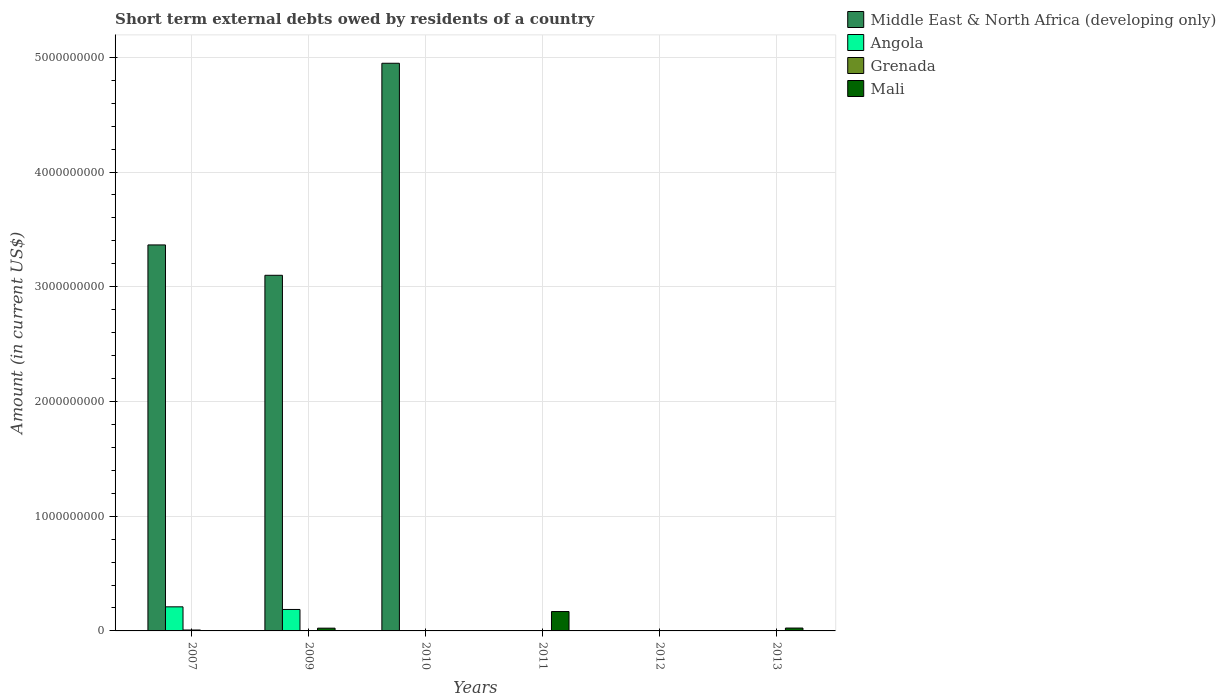How many different coloured bars are there?
Make the answer very short. 4. How many bars are there on the 3rd tick from the left?
Give a very brief answer. 2. How many bars are there on the 5th tick from the right?
Give a very brief answer. 3. What is the label of the 3rd group of bars from the left?
Offer a very short reply. 2010. What is the amount of short-term external debts owed by residents in Mali in 2011?
Provide a short and direct response. 1.69e+08. Across all years, what is the maximum amount of short-term external debts owed by residents in Grenada?
Your answer should be very brief. 8.00e+06. Across all years, what is the minimum amount of short-term external debts owed by residents in Angola?
Make the answer very short. 0. In which year was the amount of short-term external debts owed by residents in Middle East & North Africa (developing only) maximum?
Provide a succinct answer. 2010. What is the total amount of short-term external debts owed by residents in Angola in the graph?
Make the answer very short. 3.97e+08. What is the difference between the amount of short-term external debts owed by residents in Angola in 2007 and that in 2009?
Your response must be concise. 2.30e+07. What is the difference between the amount of short-term external debts owed by residents in Mali in 2011 and the amount of short-term external debts owed by residents in Middle East & North Africa (developing only) in 2010?
Provide a short and direct response. -4.78e+09. What is the average amount of short-term external debts owed by residents in Mali per year?
Ensure brevity in your answer.  3.63e+07. In the year 2013, what is the difference between the amount of short-term external debts owed by residents in Angola and amount of short-term external debts owed by residents in Mali?
Provide a succinct answer. -2.46e+07. What is the ratio of the amount of short-term external debts owed by residents in Angola in 2009 to that in 2013?
Provide a succinct answer. 424.04. Is the amount of short-term external debts owed by residents in Mali in 2009 less than that in 2013?
Your answer should be very brief. Yes. What is the difference between the highest and the second highest amount of short-term external debts owed by residents in Middle East & North Africa (developing only)?
Provide a short and direct response. 1.58e+09. What is the difference between the highest and the lowest amount of short-term external debts owed by residents in Middle East & North Africa (developing only)?
Provide a succinct answer. 4.95e+09. In how many years, is the amount of short-term external debts owed by residents in Mali greater than the average amount of short-term external debts owed by residents in Mali taken over all years?
Offer a terse response. 1. Is the sum of the amount of short-term external debts owed by residents in Mali in 2009 and 2011 greater than the maximum amount of short-term external debts owed by residents in Middle East & North Africa (developing only) across all years?
Ensure brevity in your answer.  No. Is it the case that in every year, the sum of the amount of short-term external debts owed by residents in Grenada and amount of short-term external debts owed by residents in Middle East & North Africa (developing only) is greater than the amount of short-term external debts owed by residents in Angola?
Keep it short and to the point. No. How many bars are there?
Provide a succinct answer. 11. Are all the bars in the graph horizontal?
Offer a very short reply. No. How many years are there in the graph?
Your answer should be compact. 6. Are the values on the major ticks of Y-axis written in scientific E-notation?
Your response must be concise. No. What is the title of the graph?
Give a very brief answer. Short term external debts owed by residents of a country. What is the label or title of the X-axis?
Offer a very short reply. Years. What is the label or title of the Y-axis?
Provide a short and direct response. Amount (in current US$). What is the Amount (in current US$) of Middle East & North Africa (developing only) in 2007?
Provide a short and direct response. 3.36e+09. What is the Amount (in current US$) in Angola in 2007?
Give a very brief answer. 2.10e+08. What is the Amount (in current US$) of Mali in 2007?
Give a very brief answer. 0. What is the Amount (in current US$) in Middle East & North Africa (developing only) in 2009?
Your response must be concise. 3.10e+09. What is the Amount (in current US$) in Angola in 2009?
Offer a terse response. 1.87e+08. What is the Amount (in current US$) of Grenada in 2009?
Your answer should be very brief. 0. What is the Amount (in current US$) of Mali in 2009?
Your response must be concise. 2.40e+07. What is the Amount (in current US$) of Middle East & North Africa (developing only) in 2010?
Offer a terse response. 4.95e+09. What is the Amount (in current US$) in Angola in 2010?
Your answer should be very brief. 0. What is the Amount (in current US$) of Mali in 2010?
Provide a succinct answer. 0. What is the Amount (in current US$) in Angola in 2011?
Provide a short and direct response. 0. What is the Amount (in current US$) in Mali in 2011?
Your answer should be compact. 1.69e+08. What is the Amount (in current US$) of Angola in 2012?
Your answer should be compact. 0. What is the Amount (in current US$) of Mali in 2012?
Keep it short and to the point. 0. What is the Amount (in current US$) of Middle East & North Africa (developing only) in 2013?
Your answer should be compact. 0. What is the Amount (in current US$) of Angola in 2013?
Provide a short and direct response. 4.41e+05. What is the Amount (in current US$) of Mali in 2013?
Offer a terse response. 2.50e+07. Across all years, what is the maximum Amount (in current US$) in Middle East & North Africa (developing only)?
Give a very brief answer. 4.95e+09. Across all years, what is the maximum Amount (in current US$) in Angola?
Make the answer very short. 2.10e+08. Across all years, what is the maximum Amount (in current US$) of Mali?
Offer a terse response. 1.69e+08. Across all years, what is the minimum Amount (in current US$) in Middle East & North Africa (developing only)?
Your answer should be very brief. 0. Across all years, what is the minimum Amount (in current US$) in Angola?
Provide a short and direct response. 0. Across all years, what is the minimum Amount (in current US$) of Grenada?
Offer a very short reply. 0. Across all years, what is the minimum Amount (in current US$) in Mali?
Give a very brief answer. 0. What is the total Amount (in current US$) in Middle East & North Africa (developing only) in the graph?
Offer a terse response. 1.14e+1. What is the total Amount (in current US$) of Angola in the graph?
Your answer should be very brief. 3.97e+08. What is the total Amount (in current US$) in Grenada in the graph?
Your answer should be compact. 9.00e+06. What is the total Amount (in current US$) of Mali in the graph?
Make the answer very short. 2.18e+08. What is the difference between the Amount (in current US$) of Middle East & North Africa (developing only) in 2007 and that in 2009?
Keep it short and to the point. 2.65e+08. What is the difference between the Amount (in current US$) of Angola in 2007 and that in 2009?
Offer a terse response. 2.30e+07. What is the difference between the Amount (in current US$) in Middle East & North Africa (developing only) in 2007 and that in 2010?
Your answer should be very brief. -1.58e+09. What is the difference between the Amount (in current US$) in Angola in 2007 and that in 2013?
Your answer should be very brief. 2.10e+08. What is the difference between the Amount (in current US$) in Middle East & North Africa (developing only) in 2009 and that in 2010?
Give a very brief answer. -1.85e+09. What is the difference between the Amount (in current US$) of Mali in 2009 and that in 2011?
Offer a very short reply. -1.45e+08. What is the difference between the Amount (in current US$) in Angola in 2009 and that in 2013?
Ensure brevity in your answer.  1.87e+08. What is the difference between the Amount (in current US$) in Mali in 2011 and that in 2013?
Provide a short and direct response. 1.44e+08. What is the difference between the Amount (in current US$) of Middle East & North Africa (developing only) in 2007 and the Amount (in current US$) of Angola in 2009?
Your answer should be compact. 3.18e+09. What is the difference between the Amount (in current US$) in Middle East & North Africa (developing only) in 2007 and the Amount (in current US$) in Mali in 2009?
Ensure brevity in your answer.  3.34e+09. What is the difference between the Amount (in current US$) in Angola in 2007 and the Amount (in current US$) in Mali in 2009?
Offer a terse response. 1.86e+08. What is the difference between the Amount (in current US$) of Grenada in 2007 and the Amount (in current US$) of Mali in 2009?
Your answer should be very brief. -1.60e+07. What is the difference between the Amount (in current US$) in Middle East & North Africa (developing only) in 2007 and the Amount (in current US$) in Grenada in 2010?
Ensure brevity in your answer.  3.36e+09. What is the difference between the Amount (in current US$) in Angola in 2007 and the Amount (in current US$) in Grenada in 2010?
Offer a terse response. 2.09e+08. What is the difference between the Amount (in current US$) in Middle East & North Africa (developing only) in 2007 and the Amount (in current US$) in Mali in 2011?
Keep it short and to the point. 3.20e+09. What is the difference between the Amount (in current US$) of Angola in 2007 and the Amount (in current US$) of Mali in 2011?
Your answer should be very brief. 4.10e+07. What is the difference between the Amount (in current US$) in Grenada in 2007 and the Amount (in current US$) in Mali in 2011?
Offer a very short reply. -1.61e+08. What is the difference between the Amount (in current US$) of Middle East & North Africa (developing only) in 2007 and the Amount (in current US$) of Angola in 2013?
Provide a succinct answer. 3.36e+09. What is the difference between the Amount (in current US$) in Middle East & North Africa (developing only) in 2007 and the Amount (in current US$) in Mali in 2013?
Give a very brief answer. 3.34e+09. What is the difference between the Amount (in current US$) of Angola in 2007 and the Amount (in current US$) of Mali in 2013?
Ensure brevity in your answer.  1.85e+08. What is the difference between the Amount (in current US$) of Grenada in 2007 and the Amount (in current US$) of Mali in 2013?
Offer a very short reply. -1.70e+07. What is the difference between the Amount (in current US$) of Middle East & North Africa (developing only) in 2009 and the Amount (in current US$) of Grenada in 2010?
Make the answer very short. 3.10e+09. What is the difference between the Amount (in current US$) of Angola in 2009 and the Amount (in current US$) of Grenada in 2010?
Your response must be concise. 1.86e+08. What is the difference between the Amount (in current US$) in Middle East & North Africa (developing only) in 2009 and the Amount (in current US$) in Mali in 2011?
Your answer should be very brief. 2.93e+09. What is the difference between the Amount (in current US$) in Angola in 2009 and the Amount (in current US$) in Mali in 2011?
Keep it short and to the point. 1.80e+07. What is the difference between the Amount (in current US$) of Middle East & North Africa (developing only) in 2009 and the Amount (in current US$) of Angola in 2013?
Offer a very short reply. 3.10e+09. What is the difference between the Amount (in current US$) in Middle East & North Africa (developing only) in 2009 and the Amount (in current US$) in Mali in 2013?
Ensure brevity in your answer.  3.07e+09. What is the difference between the Amount (in current US$) of Angola in 2009 and the Amount (in current US$) of Mali in 2013?
Give a very brief answer. 1.62e+08. What is the difference between the Amount (in current US$) in Middle East & North Africa (developing only) in 2010 and the Amount (in current US$) in Mali in 2011?
Provide a succinct answer. 4.78e+09. What is the difference between the Amount (in current US$) in Grenada in 2010 and the Amount (in current US$) in Mali in 2011?
Your answer should be compact. -1.68e+08. What is the difference between the Amount (in current US$) of Middle East & North Africa (developing only) in 2010 and the Amount (in current US$) of Angola in 2013?
Give a very brief answer. 4.95e+09. What is the difference between the Amount (in current US$) in Middle East & North Africa (developing only) in 2010 and the Amount (in current US$) in Mali in 2013?
Your answer should be compact. 4.92e+09. What is the difference between the Amount (in current US$) in Grenada in 2010 and the Amount (in current US$) in Mali in 2013?
Keep it short and to the point. -2.40e+07. What is the average Amount (in current US$) in Middle East & North Africa (developing only) per year?
Your answer should be compact. 1.90e+09. What is the average Amount (in current US$) of Angola per year?
Your answer should be very brief. 6.62e+07. What is the average Amount (in current US$) in Grenada per year?
Give a very brief answer. 1.50e+06. What is the average Amount (in current US$) in Mali per year?
Ensure brevity in your answer.  3.63e+07. In the year 2007, what is the difference between the Amount (in current US$) in Middle East & North Africa (developing only) and Amount (in current US$) in Angola?
Offer a very short reply. 3.15e+09. In the year 2007, what is the difference between the Amount (in current US$) in Middle East & North Africa (developing only) and Amount (in current US$) in Grenada?
Provide a short and direct response. 3.36e+09. In the year 2007, what is the difference between the Amount (in current US$) of Angola and Amount (in current US$) of Grenada?
Ensure brevity in your answer.  2.02e+08. In the year 2009, what is the difference between the Amount (in current US$) in Middle East & North Africa (developing only) and Amount (in current US$) in Angola?
Provide a short and direct response. 2.91e+09. In the year 2009, what is the difference between the Amount (in current US$) of Middle East & North Africa (developing only) and Amount (in current US$) of Mali?
Offer a terse response. 3.08e+09. In the year 2009, what is the difference between the Amount (in current US$) of Angola and Amount (in current US$) of Mali?
Offer a very short reply. 1.63e+08. In the year 2010, what is the difference between the Amount (in current US$) in Middle East & North Africa (developing only) and Amount (in current US$) in Grenada?
Provide a short and direct response. 4.95e+09. In the year 2013, what is the difference between the Amount (in current US$) of Angola and Amount (in current US$) of Mali?
Give a very brief answer. -2.46e+07. What is the ratio of the Amount (in current US$) of Middle East & North Africa (developing only) in 2007 to that in 2009?
Give a very brief answer. 1.09. What is the ratio of the Amount (in current US$) in Angola in 2007 to that in 2009?
Keep it short and to the point. 1.12. What is the ratio of the Amount (in current US$) in Middle East & North Africa (developing only) in 2007 to that in 2010?
Give a very brief answer. 0.68. What is the ratio of the Amount (in current US$) in Angola in 2007 to that in 2013?
Your answer should be very brief. 476.19. What is the ratio of the Amount (in current US$) of Middle East & North Africa (developing only) in 2009 to that in 2010?
Give a very brief answer. 0.63. What is the ratio of the Amount (in current US$) in Mali in 2009 to that in 2011?
Make the answer very short. 0.14. What is the ratio of the Amount (in current US$) of Angola in 2009 to that in 2013?
Give a very brief answer. 424.04. What is the ratio of the Amount (in current US$) in Mali in 2009 to that in 2013?
Your response must be concise. 0.96. What is the ratio of the Amount (in current US$) in Mali in 2011 to that in 2013?
Provide a short and direct response. 6.76. What is the difference between the highest and the second highest Amount (in current US$) of Middle East & North Africa (developing only)?
Ensure brevity in your answer.  1.58e+09. What is the difference between the highest and the second highest Amount (in current US$) of Angola?
Your answer should be compact. 2.30e+07. What is the difference between the highest and the second highest Amount (in current US$) of Mali?
Your answer should be compact. 1.44e+08. What is the difference between the highest and the lowest Amount (in current US$) in Middle East & North Africa (developing only)?
Offer a very short reply. 4.95e+09. What is the difference between the highest and the lowest Amount (in current US$) in Angola?
Provide a short and direct response. 2.10e+08. What is the difference between the highest and the lowest Amount (in current US$) in Grenada?
Ensure brevity in your answer.  8.00e+06. What is the difference between the highest and the lowest Amount (in current US$) in Mali?
Offer a very short reply. 1.69e+08. 